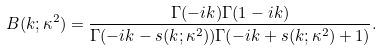Convert formula to latex. <formula><loc_0><loc_0><loc_500><loc_500>B ( k ; \kappa ^ { 2 } ) = \frac { \Gamma ( - i k ) \Gamma ( 1 - i k ) } { \Gamma ( - i k - s ( k ; \kappa ^ { 2 } ) ) \Gamma ( - i k + s ( k ; \kappa ^ { 2 } ) + 1 ) } .</formula> 